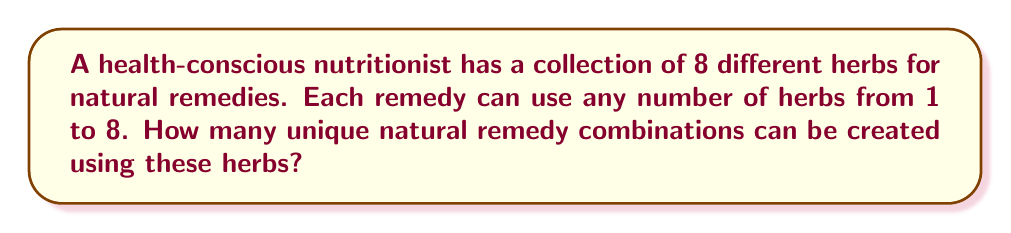Show me your answer to this math problem. Let's approach this step-by-step:

1) First, we need to understand that this is a problem of finding all possible subsets of a set, excluding the empty set (since a remedy must contain at least one herb).

2) For a set with $n$ elements, the total number of subsets is $2^n$. This includes the empty set.

3) In this case, we have 8 herbs, so $n = 8$.

4) The total number of subsets would be $2^8 = 256$.

5) However, we need to exclude the empty set, as a remedy must contain at least one herb.

6) Therefore, the number of unique remedy combinations is:

   $2^8 - 1 = 256 - 1 = 255$

This can also be calculated using the sum of combinations:

$$\sum_{k=1}^8 \binom{8}{k} = \binom{8}{1} + \binom{8}{2} + ... + \binom{8}{8}$$

Which equals 255.
Answer: 255 